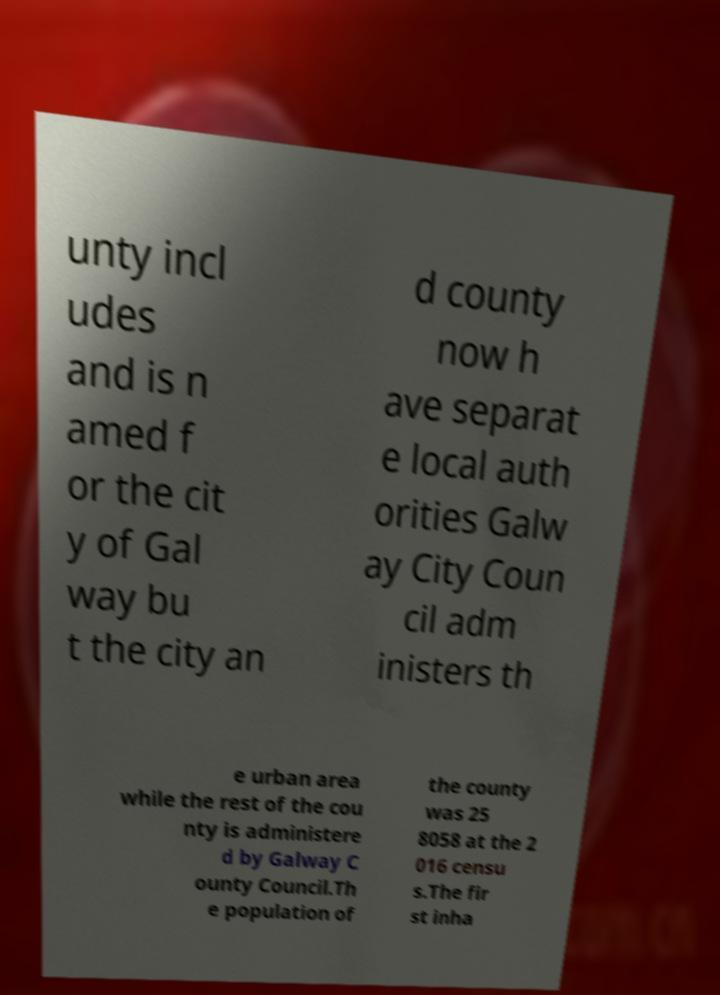I need the written content from this picture converted into text. Can you do that? unty incl udes and is n amed f or the cit y of Gal way bu t the city an d county now h ave separat e local auth orities Galw ay City Coun cil adm inisters th e urban area while the rest of the cou nty is administere d by Galway C ounty Council.Th e population of the county was 25 8058 at the 2 016 censu s.The fir st inha 